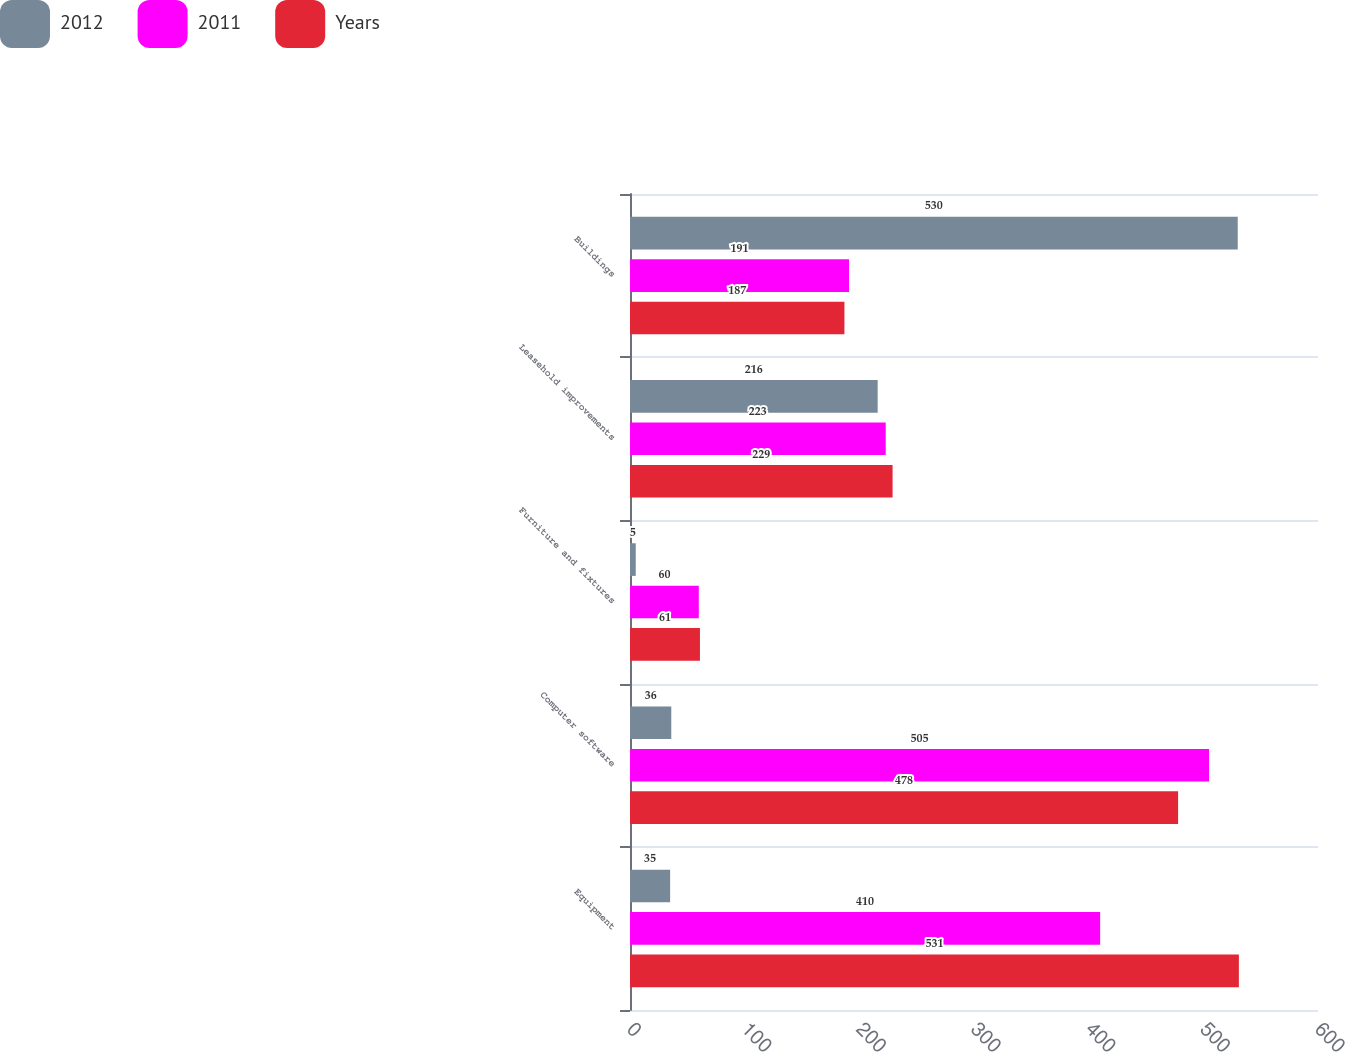Convert chart. <chart><loc_0><loc_0><loc_500><loc_500><stacked_bar_chart><ecel><fcel>Equipment<fcel>Computer software<fcel>Furniture and fixtures<fcel>Leasehold improvements<fcel>Buildings<nl><fcel>2012<fcel>35<fcel>36<fcel>5<fcel>216<fcel>530<nl><fcel>2011<fcel>410<fcel>505<fcel>60<fcel>223<fcel>191<nl><fcel>Years<fcel>531<fcel>478<fcel>61<fcel>229<fcel>187<nl></chart> 